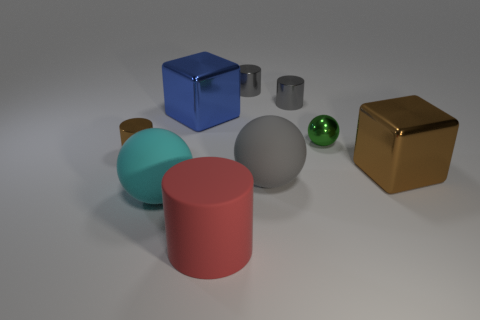There is a big gray object that is the same shape as the big cyan object; what is its material?
Provide a short and direct response. Rubber. What is the material of the big brown object?
Your response must be concise. Metal. Do the metallic cube that is left of the red rubber object and the small brown thing have the same size?
Give a very brief answer. No. What is the size of the ball that is to the right of the large gray ball?
Your answer should be compact. Small. There is a sphere that is both in front of the tiny green object and behind the cyan object; what is its color?
Your response must be concise. Gray. There is a small thing that is on the left side of the large blue metal thing; how many small objects are behind it?
Offer a very short reply. 3. What is the size of the brown cylinder that is made of the same material as the small ball?
Your response must be concise. Small. The green shiny ball has what size?
Make the answer very short. Small. Is the brown cylinder made of the same material as the gray ball?
Offer a very short reply. No. What color is the matte object that is behind the large ball that is left of the gray ball?
Make the answer very short. Gray. 